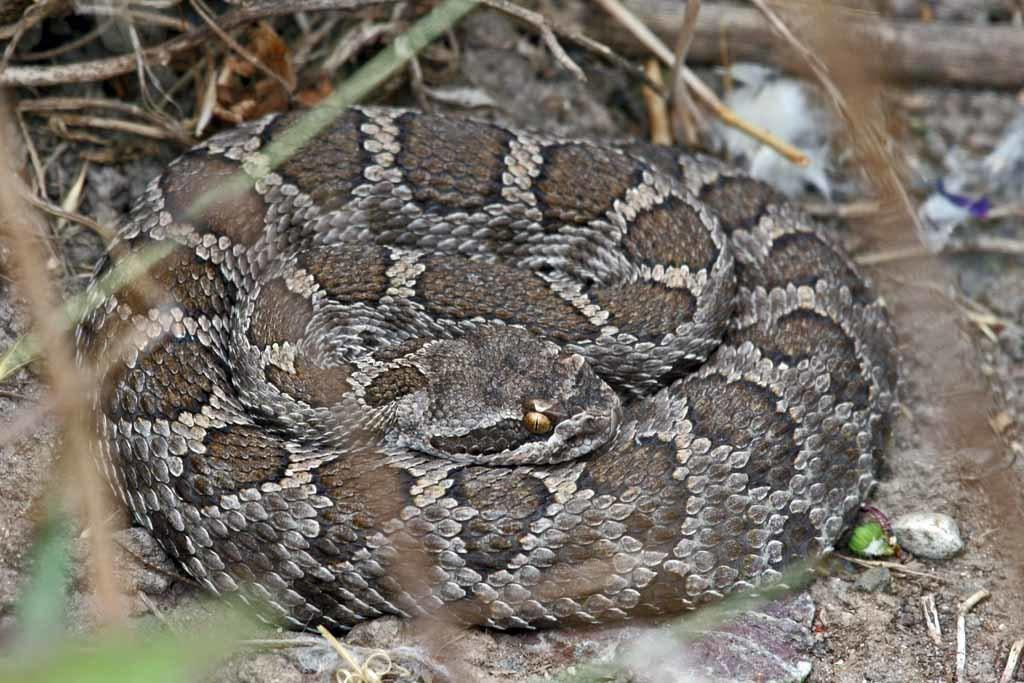What animal is present in the image? There is a snake in the image. Where is the snake located? The snake is on a path in the image. What can be seen in the background behind the snake? There are branches visible behind the snake. How many people are on the committee in the image? There is no committee present in the image; it features a snake on a path with branches in the background. 